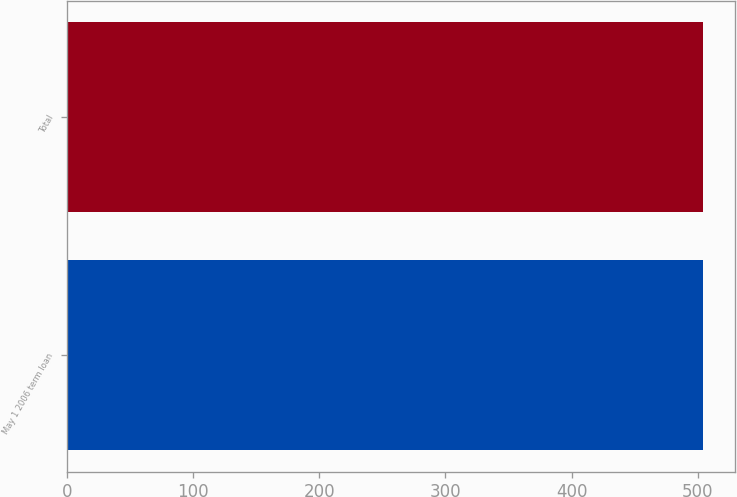<chart> <loc_0><loc_0><loc_500><loc_500><bar_chart><fcel>May 1 2006 term loan<fcel>Total<nl><fcel>504<fcel>504.1<nl></chart> 